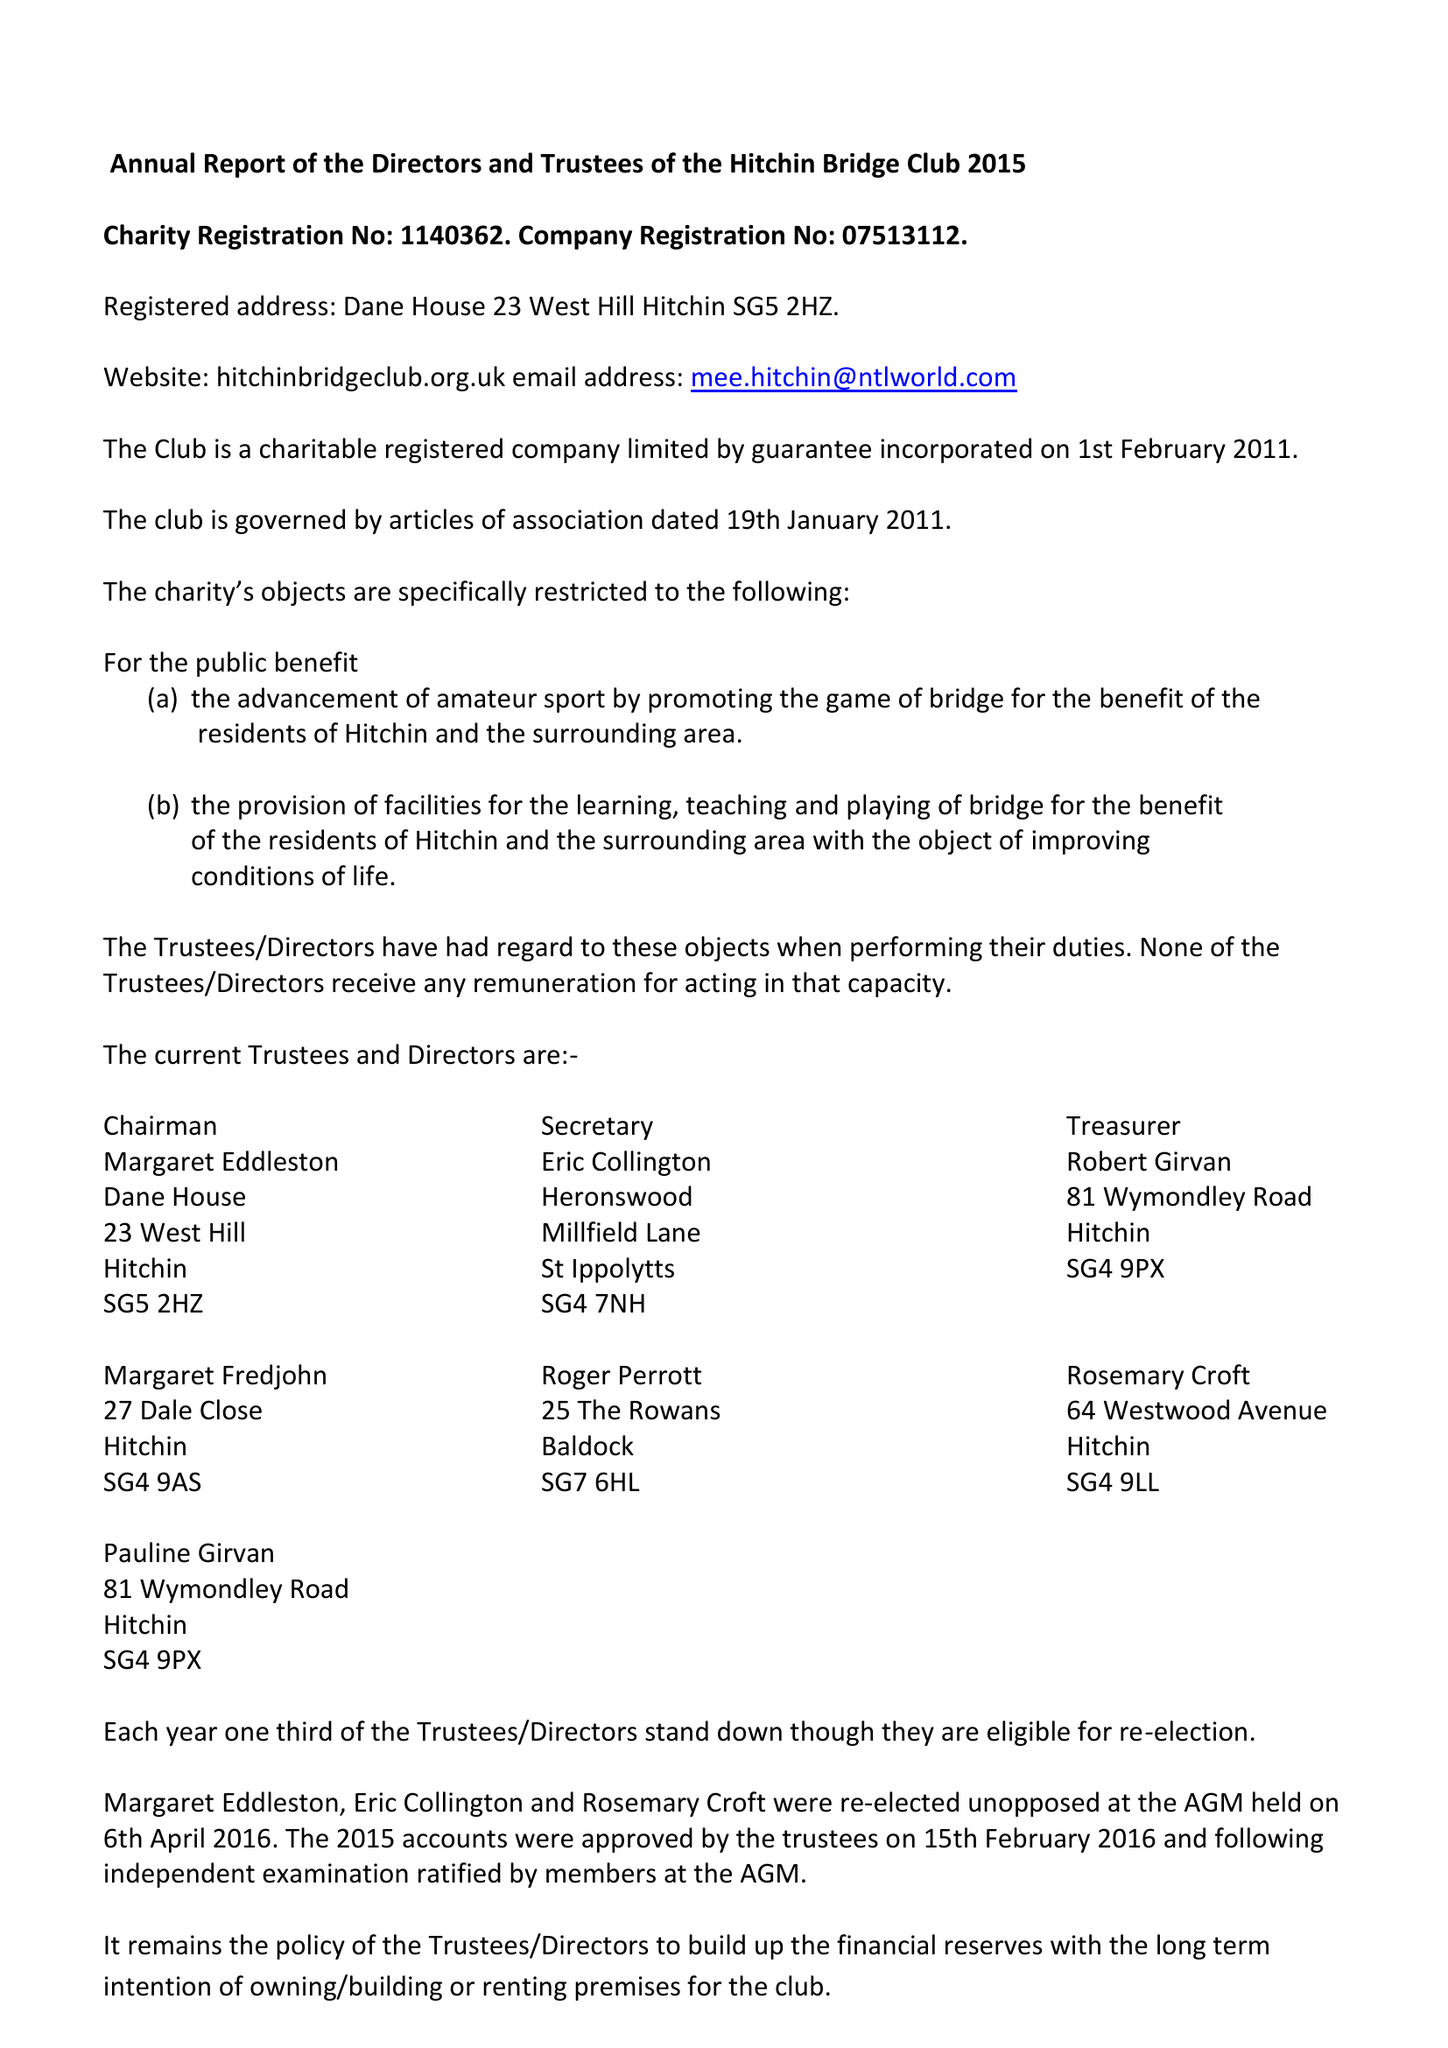What is the value for the charity_name?
Answer the question using a single word or phrase. Hitchin Bridge Club 